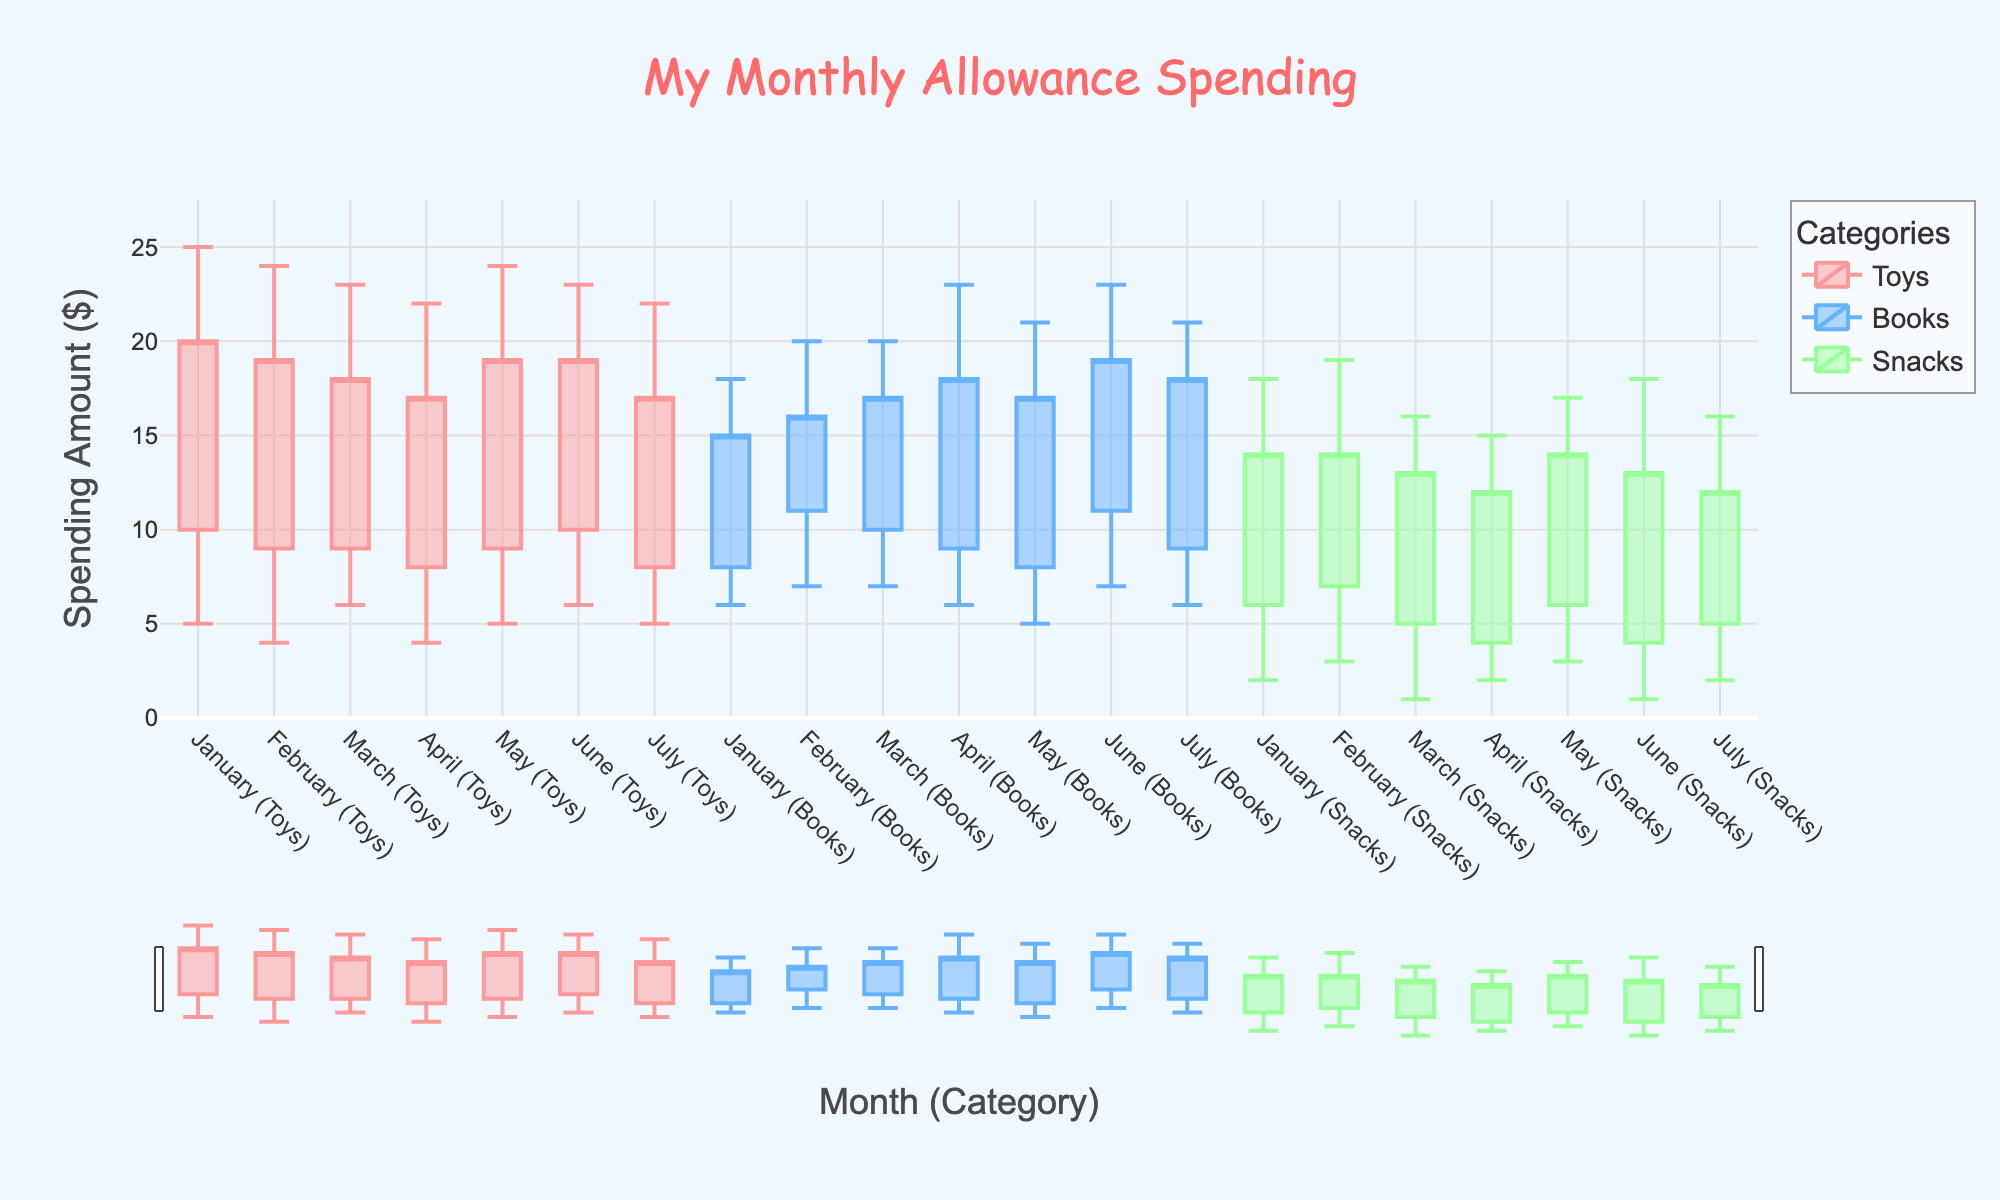What is the maximum spending on toys in January? The maximum spending on toys in January is represented by the top edge of the candlestick for January (Toys). You can see this value at the highest point of the bar.
Answer: 25 Which category had the highest median spending in April? To find the category with the highest median spending in April, look at the middle line inside each candlestick for April (Toys), April (Books), and April (Snacks). Compare these median lines to see which is the highest.
Answer: Books What is the range (difference between maximum and minimum spending) for snacks in February? The range is calculated by subtracting the minimum spending from the maximum spending for February (Snacks). According to the plot, maximum = 19 and minimum = 3, giving a range of 19 - 3 = 16.
Answer: 16 In which month did spending on books have the lowest minimum spending? Find the lowest point on the candlestick for each month under the Books category. Compare these low points to determine the month with the lowest value.
Answer: May How does the IQR (Interquartile Range) for snacks in March compare to the IQR for books in the same month? The IQR is the difference between Q3 and Q1. For snacks in March, it’s Q3 (13) - Q1 (5) = 8. For books in March, it’s Q3 (17) - Q1 (10) = 7. Therefore, the IQR for snacks in March is larger than for books.
Answer: IQR for snacks is larger Which month had the most consistent spending (smallest range) on toys? Consistent spending means the smallest range. Calculate the range (max - min) for the Toys category for each month and find the smallest value.
Answer: April How did the Q1 spending on books in June compare to Q1 spending on toys in June? Look at the bottom edge of the boxes in the candlesticks for June (Books) and June (Toys) which represent Q1 spending. Compare these two values.
Answer: Books higher than Toys Which category had the most variable spending (largest range) in January? The most variable spending will have the longest candlestick. Calculate the range (max - min) for each category in January and find the largest value.
Answer: Toys In which month did the median spending on snacks increase compared to the previous month? Check the center line inside the candlestick for Snacks in each month. Compare consecutive months to see where the median value increased from one month to the next.
Answer: February What's the average median spending across all categories in March? To find the average, add the median spending for each category in March and divide by the number of categories: (13 + 15 + 9) / 3 = 37 / 3 ≈ 12.33.
Answer: 12.33 